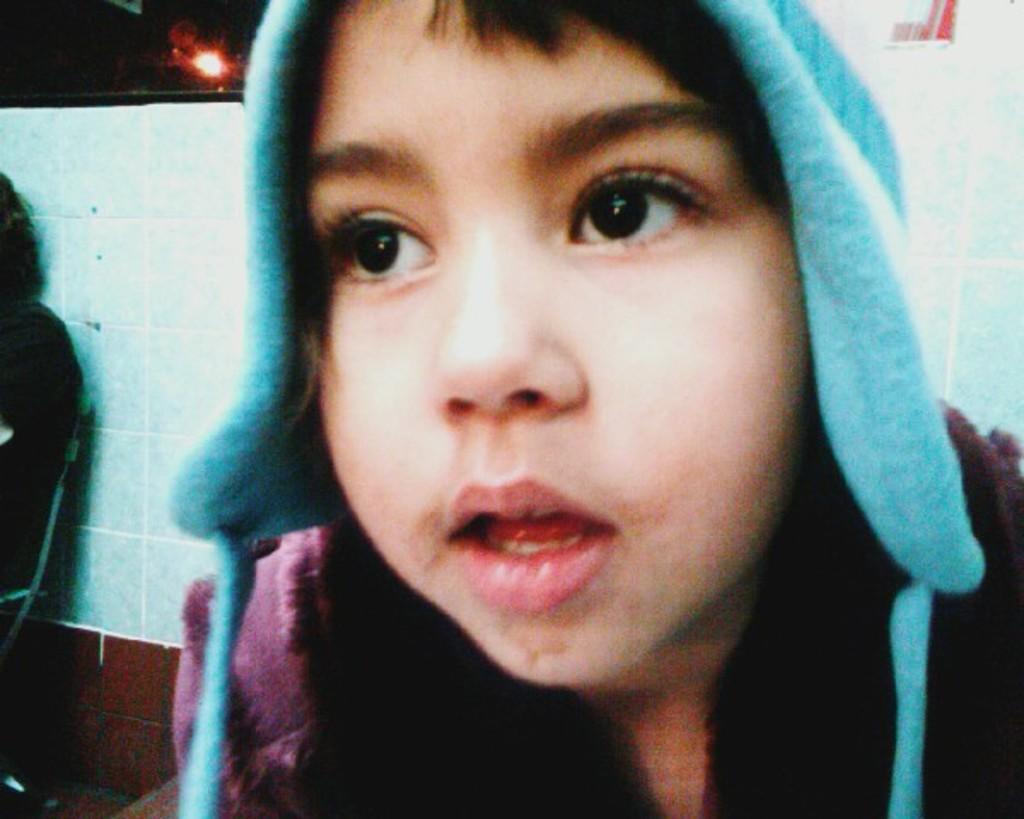Please provide a concise description of this image. In the center of the image we can see a boy. In the background we can see the tile wall and there is also a person sitting on the chair. We can also see the light. 